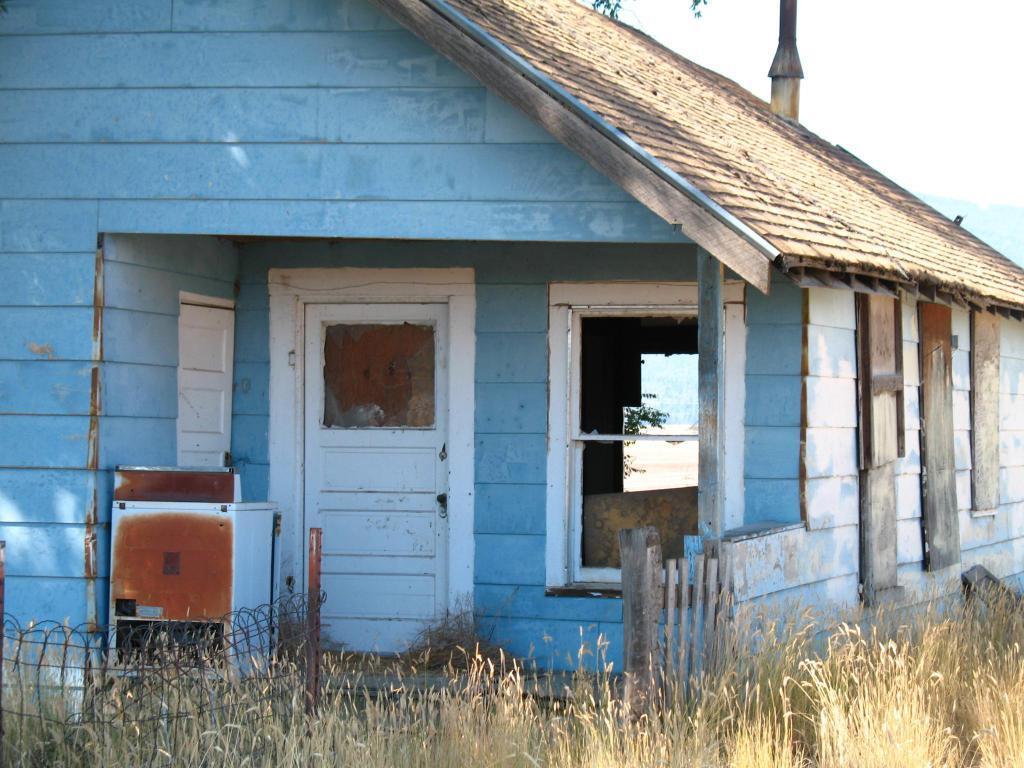In one or two sentences, can you explain what this image depicts? In this picture we can see a house, roof top, door, window, railing and few objects. At the bottom portion of the picture we can see plants. 